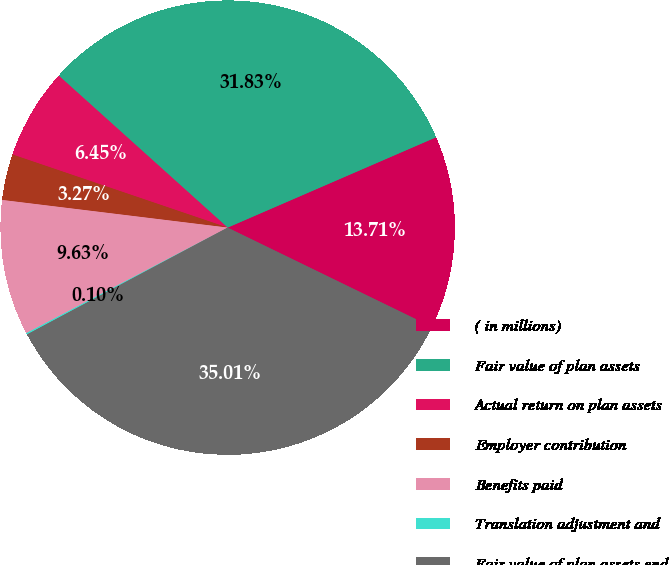<chart> <loc_0><loc_0><loc_500><loc_500><pie_chart><fcel>( in millions)<fcel>Fair value of plan assets<fcel>Actual return on plan assets<fcel>Employer contribution<fcel>Benefits paid<fcel>Translation adjustment and<fcel>Fair value of plan assets end<nl><fcel>13.71%<fcel>31.83%<fcel>6.45%<fcel>3.27%<fcel>9.63%<fcel>0.1%<fcel>35.01%<nl></chart> 